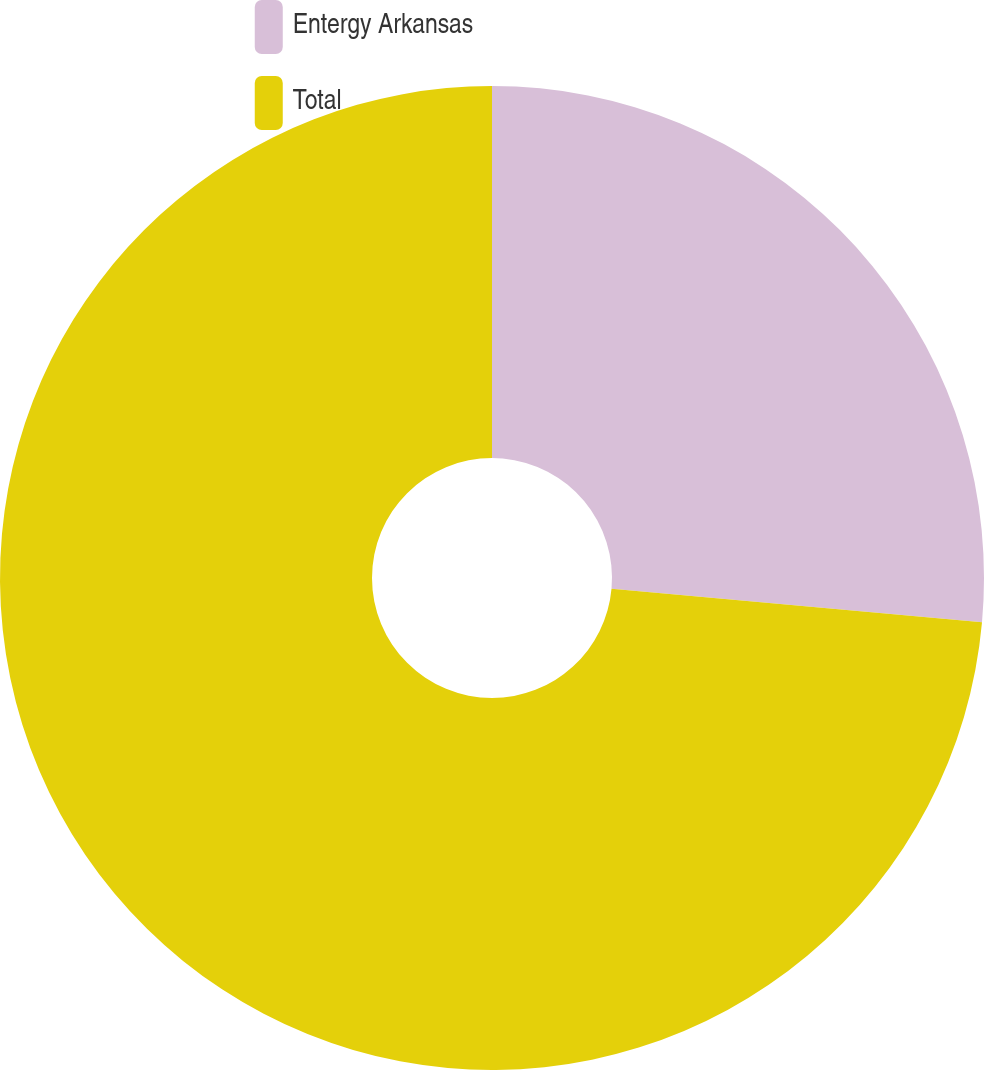Convert chart to OTSL. <chart><loc_0><loc_0><loc_500><loc_500><pie_chart><fcel>Entergy Arkansas<fcel>Total<nl><fcel>26.43%<fcel>73.57%<nl></chart> 